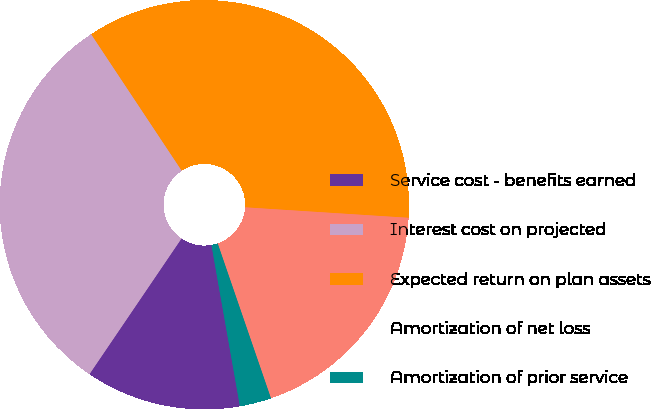Convert chart to OTSL. <chart><loc_0><loc_0><loc_500><loc_500><pie_chart><fcel>Service cost - benefits earned<fcel>Interest cost on projected<fcel>Expected return on plan assets<fcel>Amortization of net loss<fcel>Amortization of prior service<nl><fcel>12.27%<fcel>31.19%<fcel>35.34%<fcel>18.71%<fcel>2.49%<nl></chart> 